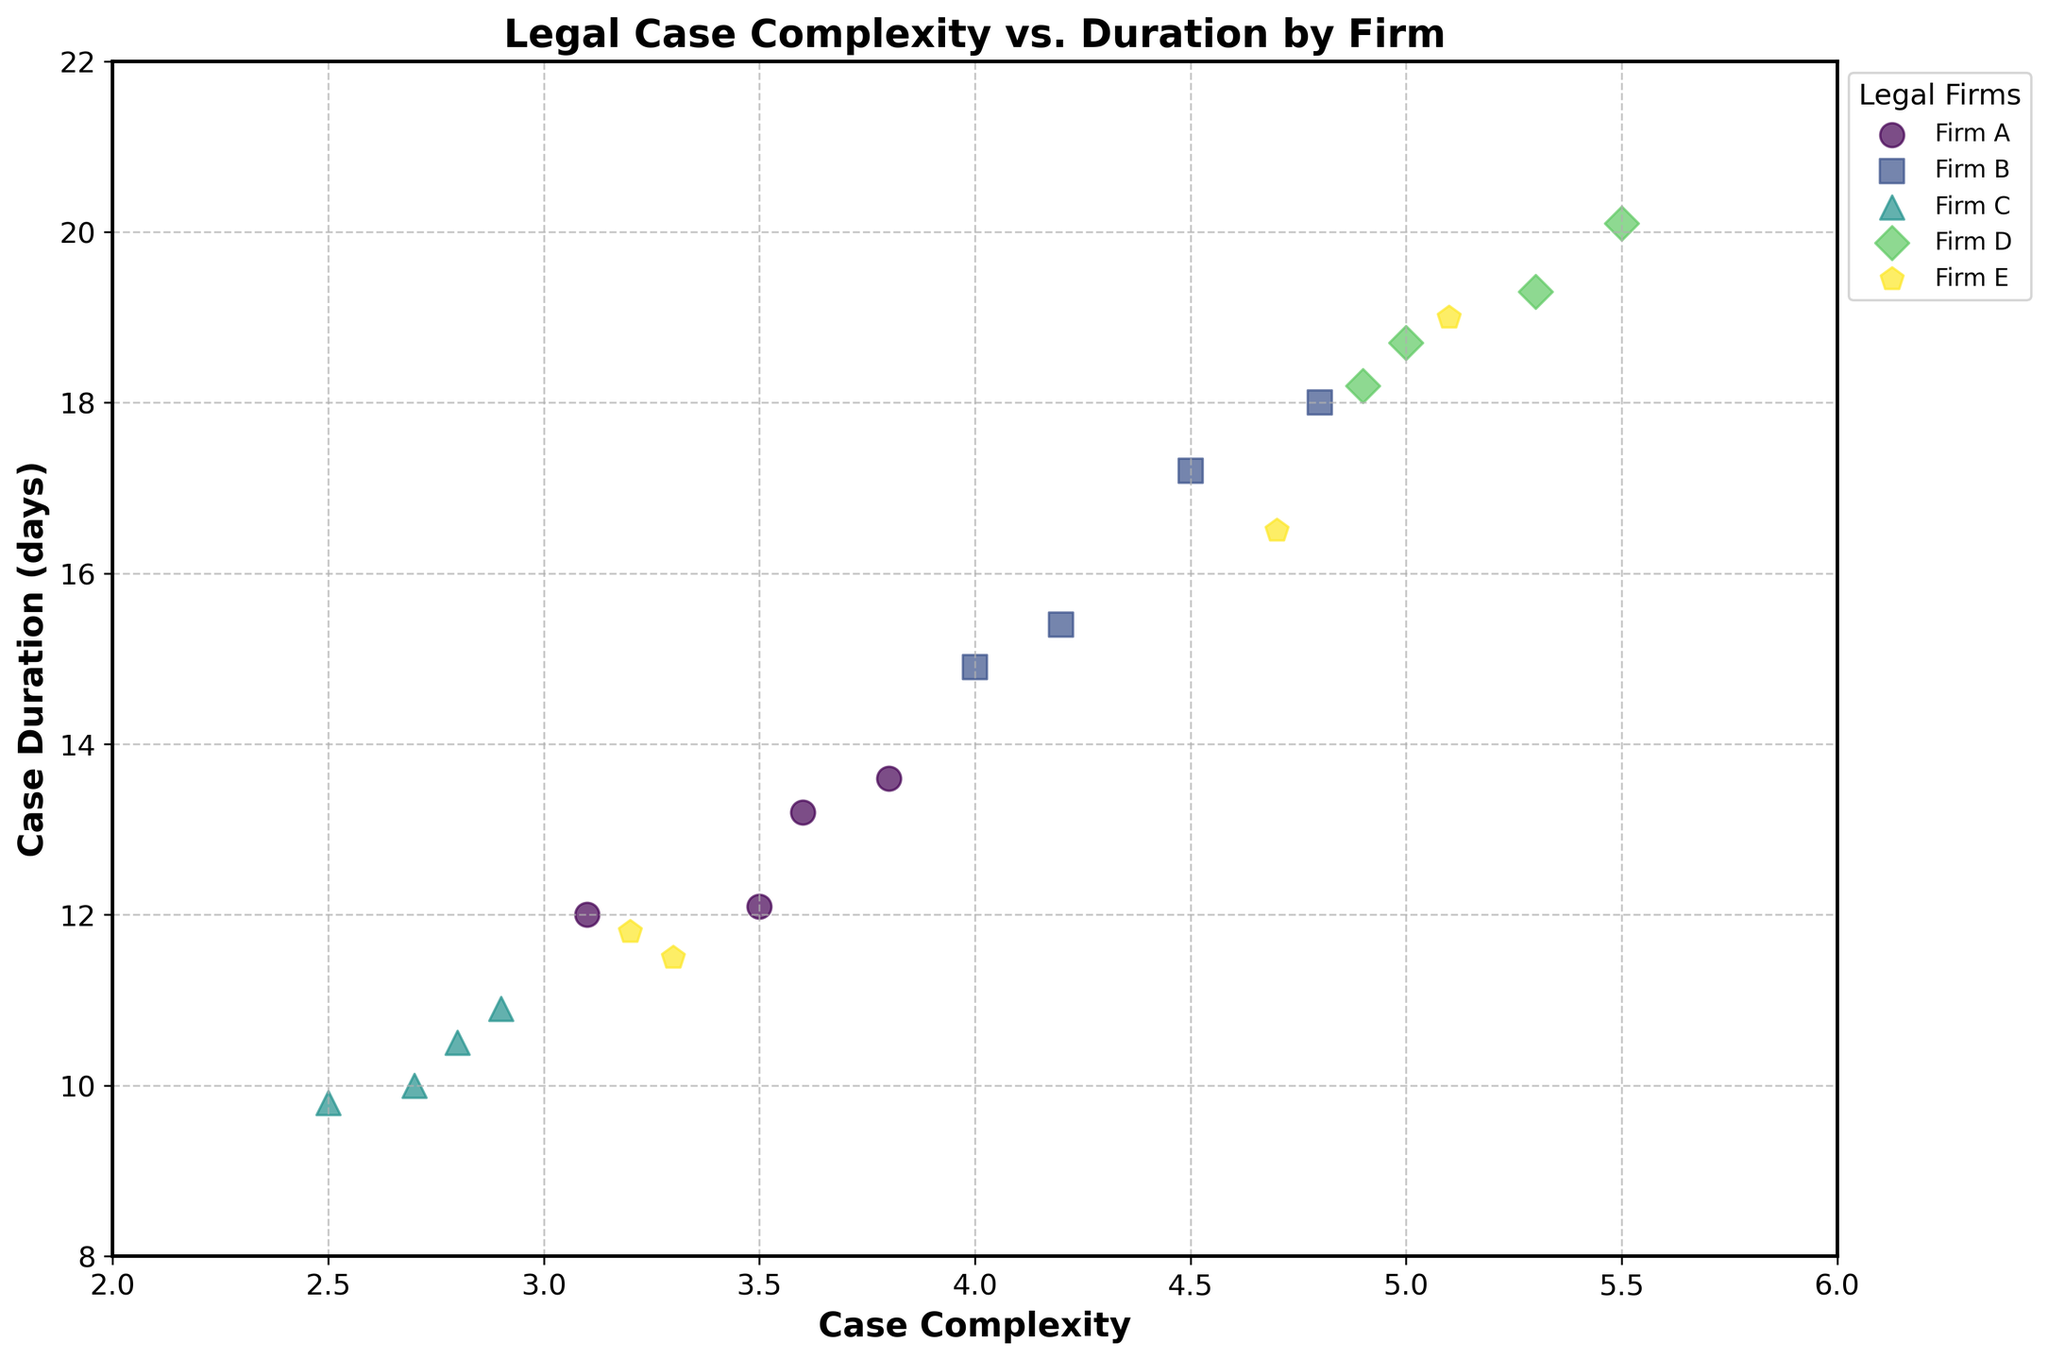What is the title of the scatter plot? The title of the plot is displayed at the top center of the figure in bold font. It provides an overall description of what the plot is about.
Answer: Legal Case Complexity vs. Duration by Firm Which Legal Firm has the highest Case Duration? By observing the data points and the legend on the plot, we see that Firm D data points are located higher on the vertical axis, indicating longer case durations.
Answer: Firm D How many Legal Firms are represented in the plot? The number of unique markers and colors in the plot determines the number of legal firms. Each firm has a distinct marker and color.
Answer: 5 What is the relationship between Case Complexity and Case Duration in the plot? By observing the scatter plot, an upward trend indicates that as Case Complexity increases, Case Duration also increases.
Answer: Positive correlation Which Legal Firm has the most cases with a Case Complexity above 4.5? By looking at the scatter points and the legend, Firm D has the most data points above the Case Complexity value of 4.5.
Answer: Firm D What is the average Case Duration for Firm A? Identifying the data points for Firm A, we find their Case Durations to be 12.1, 13.6, 12.0, and 13.2. Adding up these values and dividing by 4 gives the average duration.
Answer: 12.725 Which Legal Firm has cases with the smallest overall range of Case Duration? By comparing the range (the difference between maximum and minimum values) of Case Duration for each firm, Firm C has the smallest range from 9.8 to 10.9.
Answer: Firm C For which Case Complexity do we observe the greatest variation in Case Duration among different firms? By finding the case complexity where data points have the greatest spread in the vertical axis (case duration), the widest spread is observed around the Case Complexity of 4.8.
Answer: 4.8 Are there any outliers in the scatter plot? An outlier is a data point that significantly differs from others. Checking the scatter plot, the point for Firm D at Case Complexity 5.5 and Case Duration 20.1 stands out.
Answer: Yes, Firm D at (5.5, 20.1) What are the x-axis and y-axis labels in the plot? These labels are displayed along the horizontal and vertical axes. They indicate what each axis represents: case complexity and duration in days.
Answer: Case Complexity and Case Duration (days) 